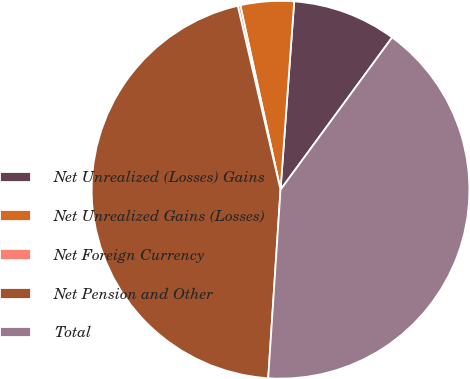<chart> <loc_0><loc_0><loc_500><loc_500><pie_chart><fcel>Net Unrealized (Losses) Gains<fcel>Net Unrealized Gains (Losses)<fcel>Net Foreign Currency<fcel>Net Pension and Other<fcel>Total<nl><fcel>8.91%<fcel>4.57%<fcel>0.22%<fcel>45.33%<fcel>40.98%<nl></chart> 